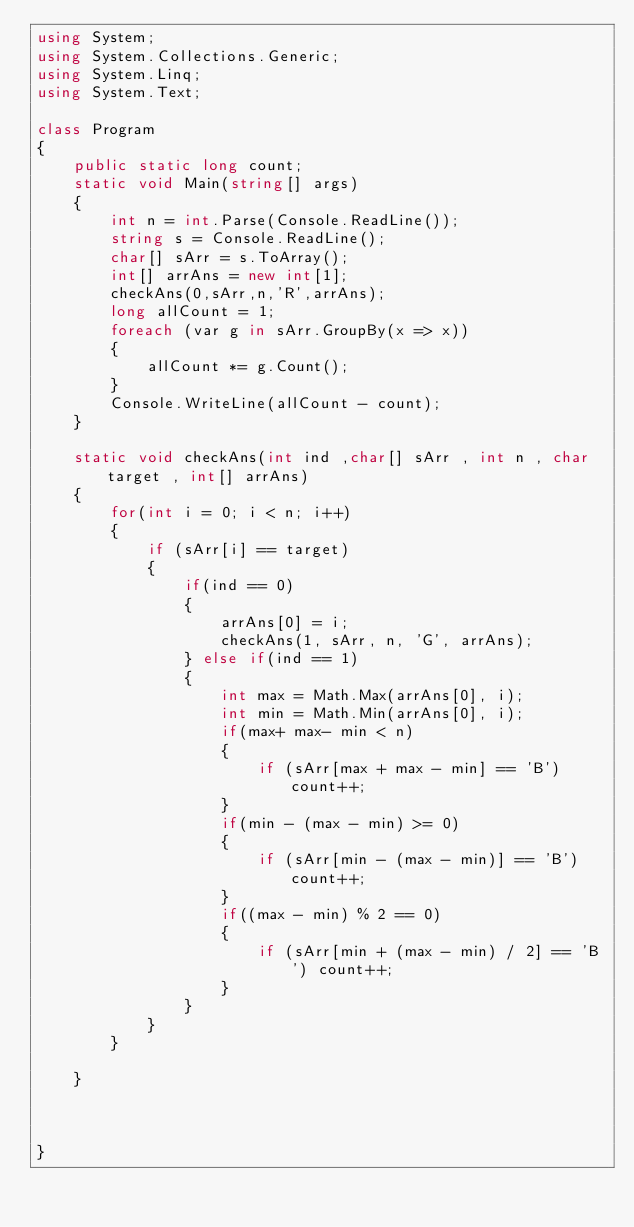<code> <loc_0><loc_0><loc_500><loc_500><_C#_>using System;
using System.Collections.Generic;
using System.Linq;
using System.Text;

class Program
{
    public static long count;
    static void Main(string[] args)
    {
        int n = int.Parse(Console.ReadLine());
        string s = Console.ReadLine();
        char[] sArr = s.ToArray();
        int[] arrAns = new int[1];
        checkAns(0,sArr,n,'R',arrAns);
        long allCount = 1;
        foreach (var g in sArr.GroupBy(x => x))
        {
            allCount *= g.Count();
        }
        Console.WriteLine(allCount - count);
    }

    static void checkAns(int ind ,char[] sArr , int n , char target , int[] arrAns)
    {
        for(int i = 0; i < n; i++)
        {
            if (sArr[i] == target)
            {
                if(ind == 0)
                {
                    arrAns[0] = i;
                    checkAns(1, sArr, n, 'G', arrAns);
                } else if(ind == 1)
                {
                    int max = Math.Max(arrAns[0], i);
                    int min = Math.Min(arrAns[0], i);
                    if(max+ max- min < n)
                    {
                        if (sArr[max + max - min] == 'B') count++;
                    }
                    if(min - (max - min) >= 0)
                    {
                        if (sArr[min - (max - min)] == 'B') count++;
                    }
                    if((max - min) % 2 == 0)
                    {
                        if (sArr[min + (max - min) / 2] == 'B') count++;
                    }
                }
            }
        }

    }



}


</code> 